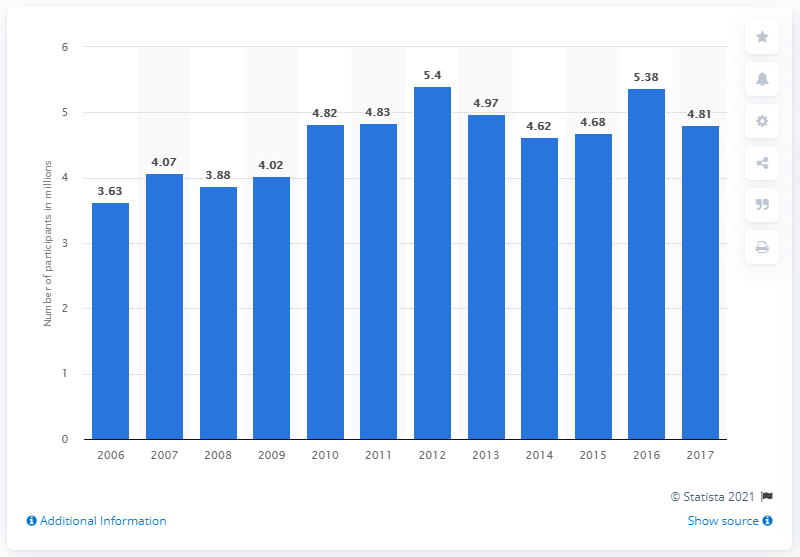Indicate a few pertinent items in this graphic. In 2017, the number of U.S. gymnasts was 4.81. 